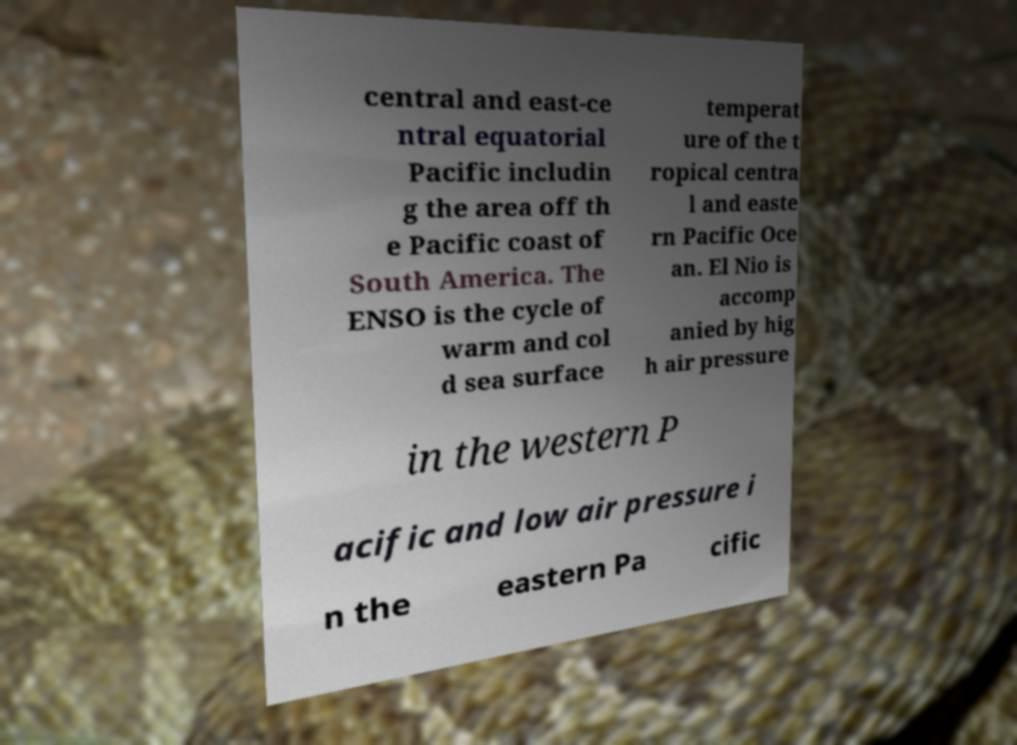Could you extract and type out the text from this image? central and east-ce ntral equatorial Pacific includin g the area off th e Pacific coast of South America. The ENSO is the cycle of warm and col d sea surface temperat ure of the t ropical centra l and easte rn Pacific Oce an. El Nio is accomp anied by hig h air pressure in the western P acific and low air pressure i n the eastern Pa cific 